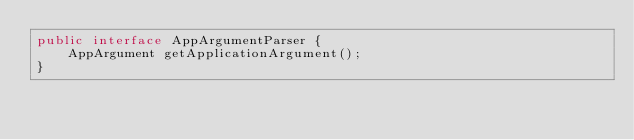<code> <loc_0><loc_0><loc_500><loc_500><_Java_>public interface AppArgumentParser {
    AppArgument getApplicationArgument();
}
</code> 